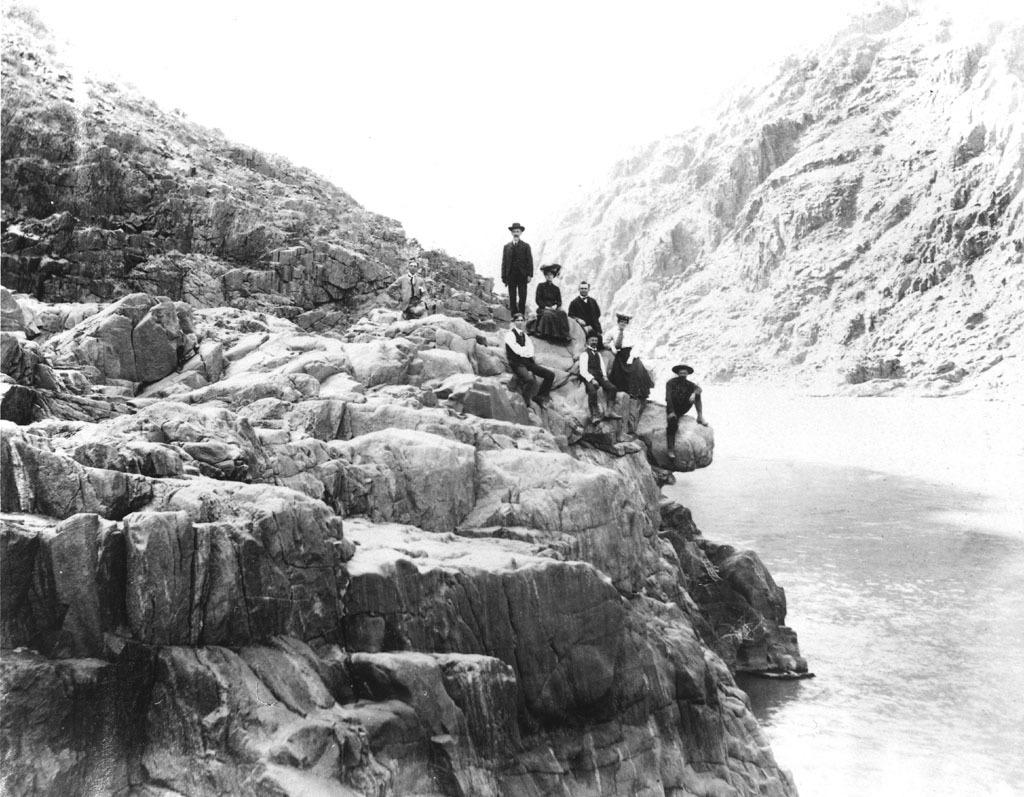What type of water feature is present in the image? There is a canal in the image. How is the canal positioned in relation to the surrounding landscape? The canal is situated between hills. Are there any people visible in the image? Yes, there are persons on the hill. What can be seen at the top of the image? The sky is visible at the top of the image. What type of basketball court can be seen on the hill in the image? There is no basketball court present in the image; it features a canal situated between hills with persons on the hill. 